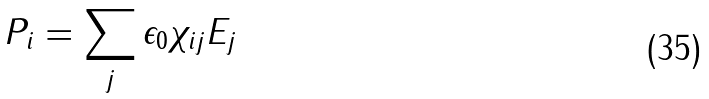Convert formula to latex. <formula><loc_0><loc_0><loc_500><loc_500>P _ { i } = \sum _ { j } \epsilon _ { 0 } \chi _ { i j } E _ { j }</formula> 